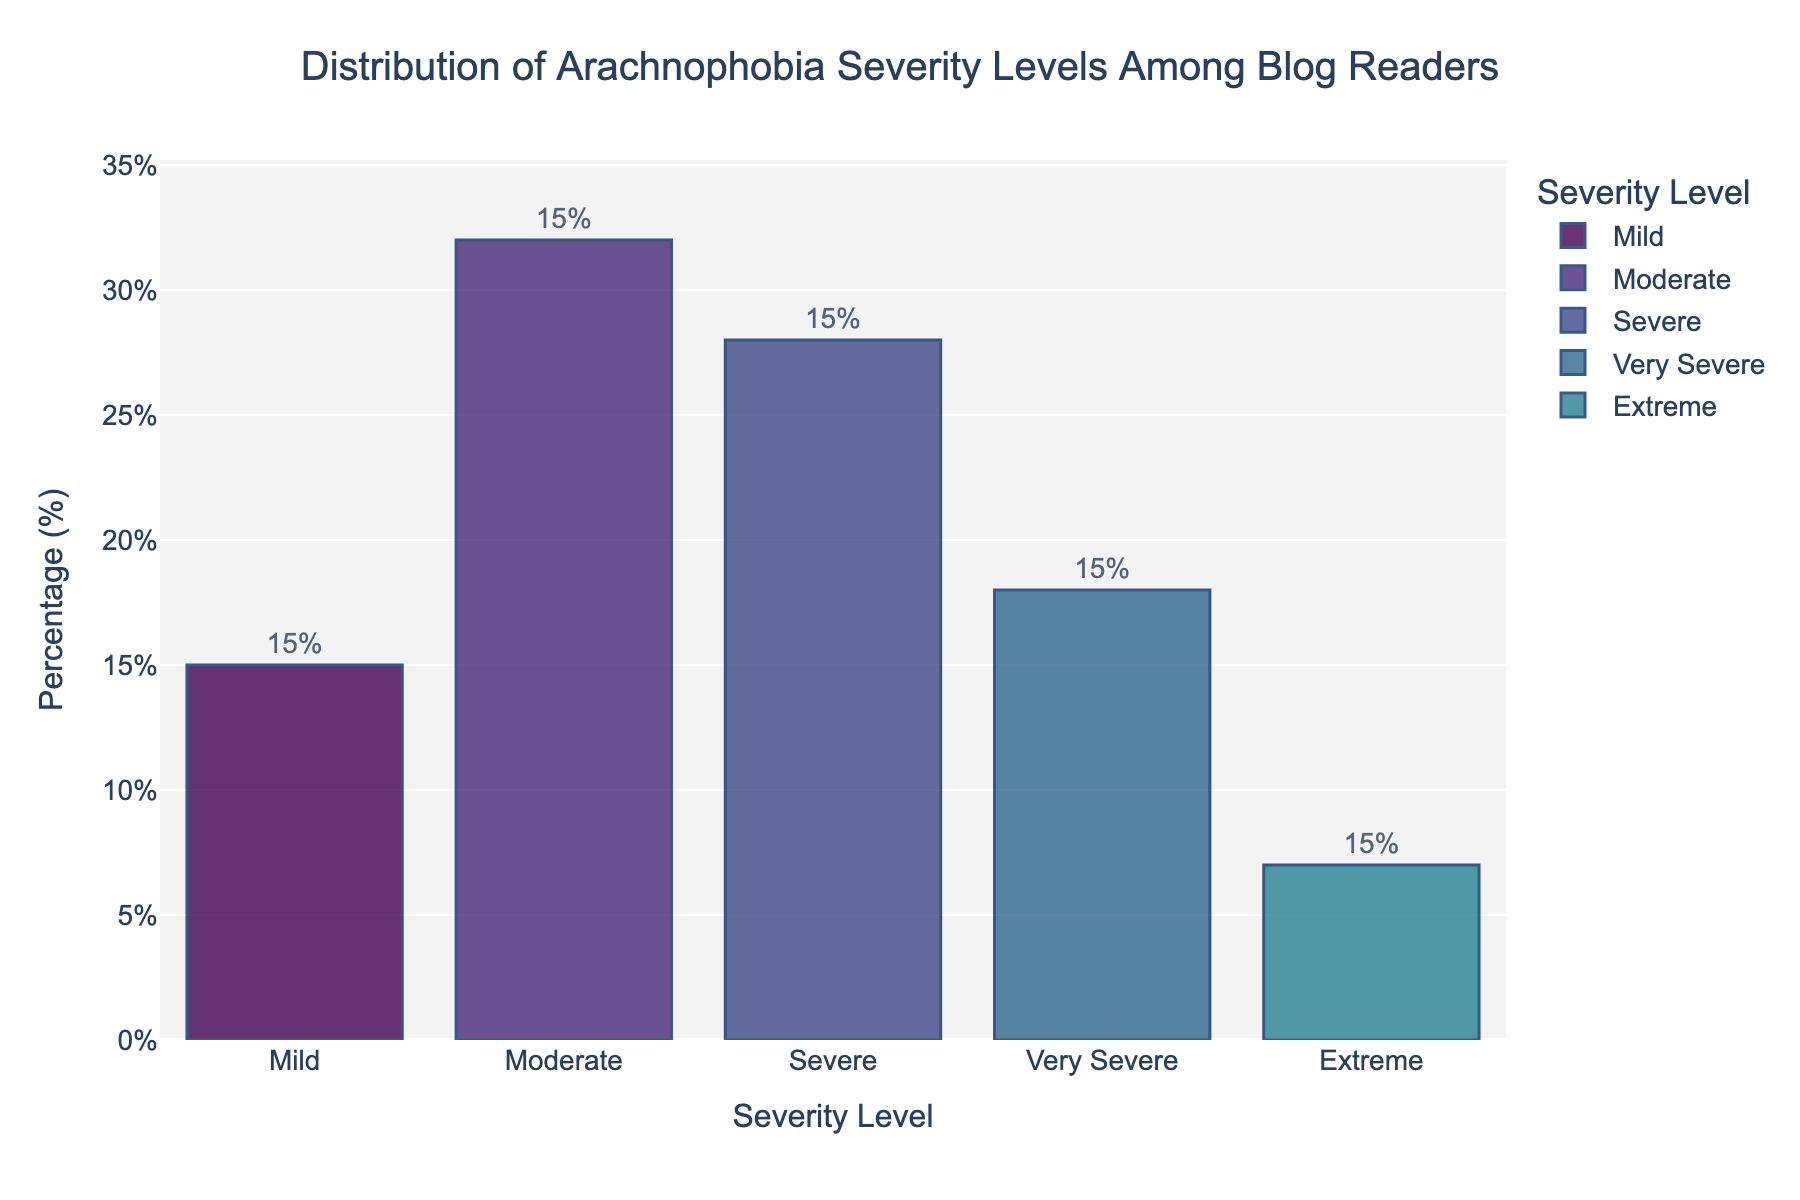What is the severity level with the highest percentage of readers? The bar labeled "Moderate" is the tallest in the chart, indicating that it has the highest percentage of readers.
Answer: Moderate What is the combined percentage of readers with Severe and Very Severe arachnophobia? The bar for Severe is 28%, and the bar for Very Severe is 18%. Adding these two percentages together gives 28 + 18 = 46%.
Answer: 46% Which severity level has the smallest percentage of readers? The shortest bar represents the severity level with the smallest percentage, which is "Extreme" at 7%.
Answer: Extreme Is the percentage of readers with Moderate arachnophobia greater than those with Severe arachnophobia? The bar for Moderate is marked at 32%, while the bar for Severe is marked at 28%. Since 32% is greater than 28%, the percentage for Moderate is indeed greater.
Answer: Yes What is the average percentage of readers for Very Severe and Extreme arachnophobia levels? The percentages for Very Severe and Extreme are 18% and 7%, respectively. The average is (18 + 7) / 2 = 12.5%.
Answer: 12.5% What are the two severity levels with the combined percentage closest to 50%? Calculating: (Mild 15% + Very Severe 18% = 33%), (Very Severe 18% + Extreme 7% = 25%), (Mild 15% + Severe 28% = 43%), (Severe 28% + Very Severe 18% = 46%), and (Moderate 32% + Severe 28% = 60%). The combination closest to 50% is Severe (28%) and Very Severe (18%) equaling 46%.
Answer: Severe and Very Severe What is the difference in percentages between readers with Mild and Extreme arachnophobia? The bar for Mild arachnophobia shows 15%, while the bar for Extreme shows 7%. The difference is 15 - 7 = 8%.
Answer: 8% Is the sum of readers with Mild and Moderate arachnophobia levels greater than those with Severe, Very Severe, and Extreme combined? Adding Mild and Moderate: 15 + 32 = 47%. Adding Severe, Very Severe, and Extreme: 28 + 18 + 7 = 53%. Since 53% is greater than 47%, the sum of Severe, Very Severe, and Extreme is greater.
Answer: No What is the median percentage level among all severity categories? The percentages are 15%, 32%, 28%, 18%, and 7%. Ordering them: 7%, 15%, 18%, 28%, 32%. The middle value (median) is 18%.
Answer: 18% What is the total percentage of readers with either Mild or Moderate arachnophobia? Adding the percentages for Mild (15%) and Moderate (32%) results in 15 + 32 = 47%.
Answer: 47% 